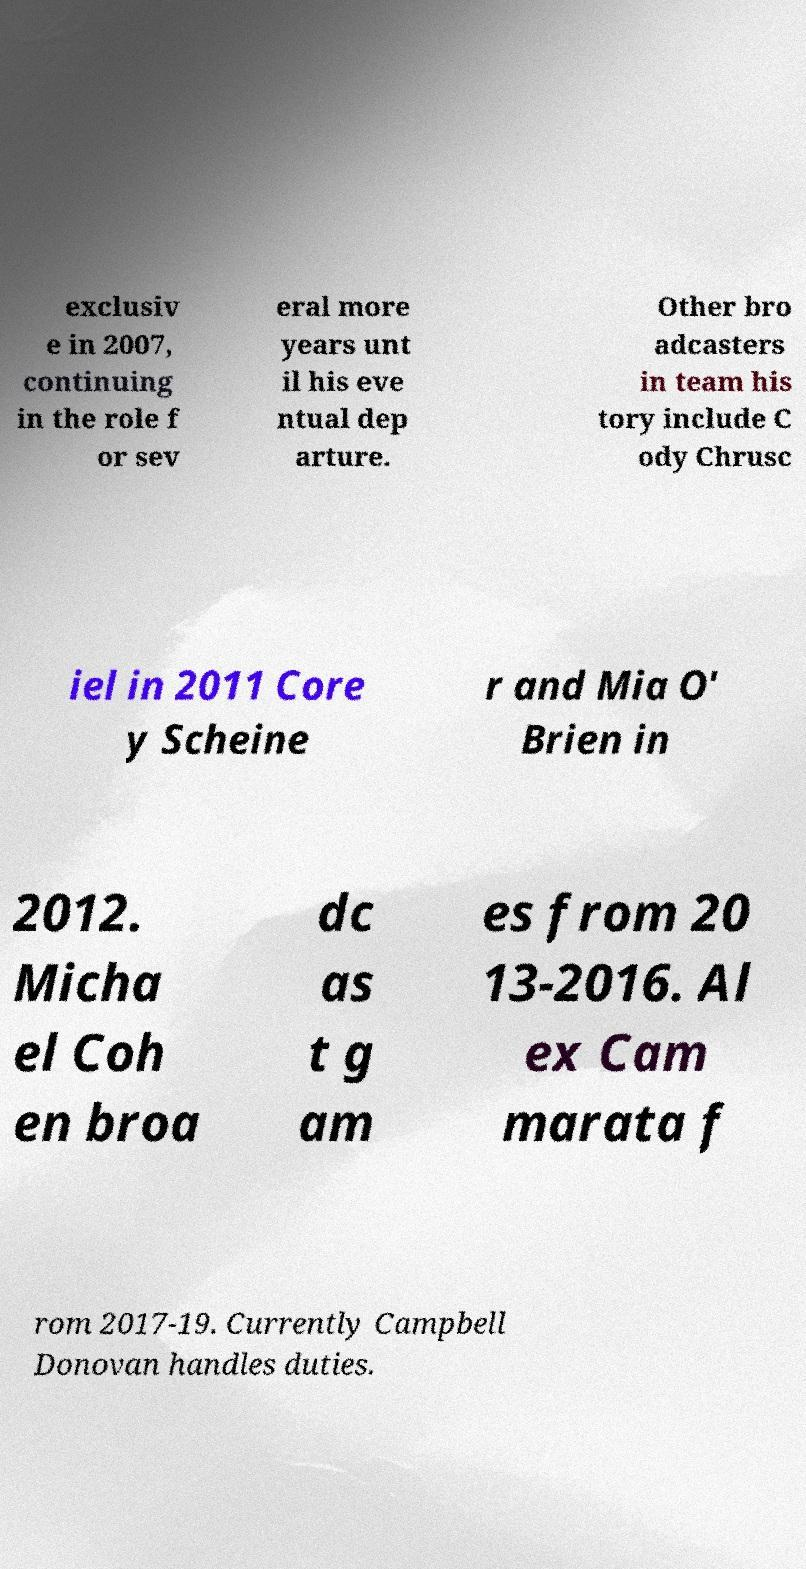Can you read and provide the text displayed in the image?This photo seems to have some interesting text. Can you extract and type it out for me? exclusiv e in 2007, continuing in the role f or sev eral more years unt il his eve ntual dep arture. Other bro adcasters in team his tory include C ody Chrusc iel in 2011 Core y Scheine r and Mia O' Brien in 2012. Micha el Coh en broa dc as t g am es from 20 13-2016. Al ex Cam marata f rom 2017-19. Currently Campbell Donovan handles duties. 